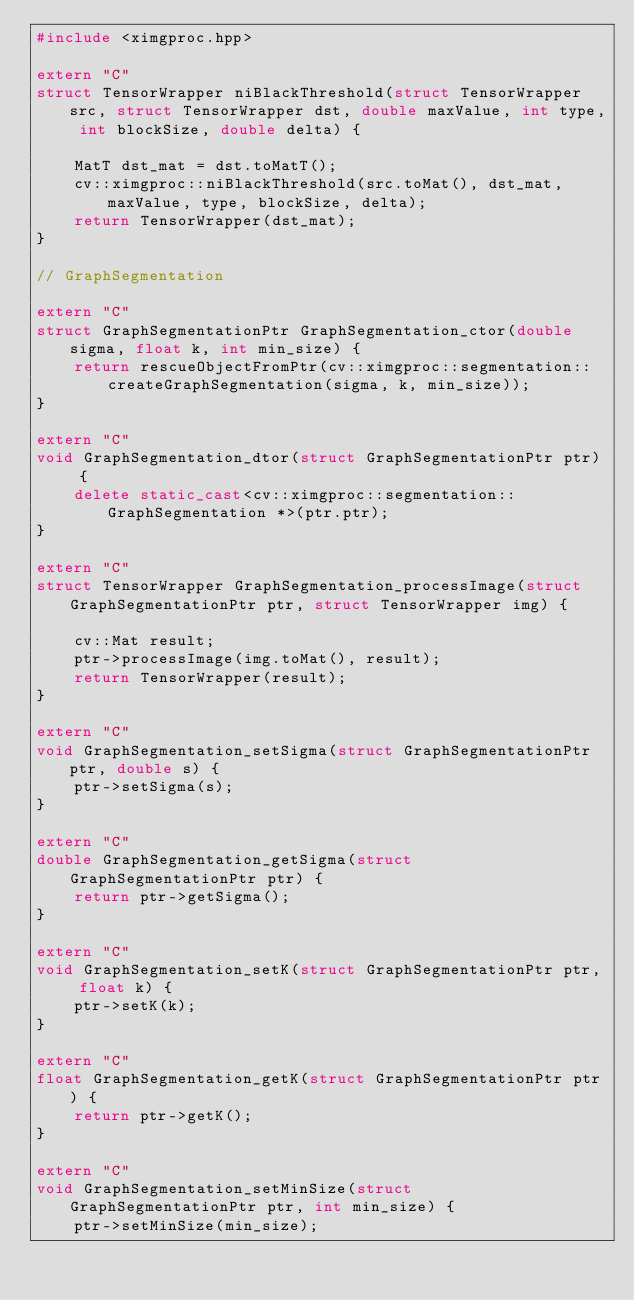Convert code to text. <code><loc_0><loc_0><loc_500><loc_500><_C++_>#include <ximgproc.hpp>

extern "C"
struct TensorWrapper niBlackThreshold(struct TensorWrapper src, struct TensorWrapper dst, double maxValue, int type, int blockSize, double delta) {

    MatT dst_mat = dst.toMatT();
    cv::ximgproc::niBlackThreshold(src.toMat(), dst_mat, maxValue, type, blockSize, delta);
    return TensorWrapper(dst_mat);
}

// GraphSegmentation

extern "C"
struct GraphSegmentationPtr GraphSegmentation_ctor(double sigma, float k, int min_size) {
    return rescueObjectFromPtr(cv::ximgproc::segmentation::createGraphSegmentation(sigma, k, min_size));
}

extern "C"
void GraphSegmentation_dtor(struct GraphSegmentationPtr ptr) {
    delete static_cast<cv::ximgproc::segmentation::GraphSegmentation *>(ptr.ptr);
}

extern "C"
struct TensorWrapper GraphSegmentation_processImage(struct GraphSegmentationPtr ptr, struct TensorWrapper img) {

    cv::Mat result;
    ptr->processImage(img.toMat(), result);
    return TensorWrapper(result);
}

extern "C"
void GraphSegmentation_setSigma(struct GraphSegmentationPtr ptr, double s) {
    ptr->setSigma(s);
}

extern "C"
double GraphSegmentation_getSigma(struct GraphSegmentationPtr ptr) {
    return ptr->getSigma();
}

extern "C"
void GraphSegmentation_setK(struct GraphSegmentationPtr ptr, float k) {
    ptr->setK(k);
}

extern "C"
float GraphSegmentation_getK(struct GraphSegmentationPtr ptr) {
    return ptr->getK();
}

extern "C"
void GraphSegmentation_setMinSize(struct GraphSegmentationPtr ptr, int min_size) {
    ptr->setMinSize(min_size);</code> 